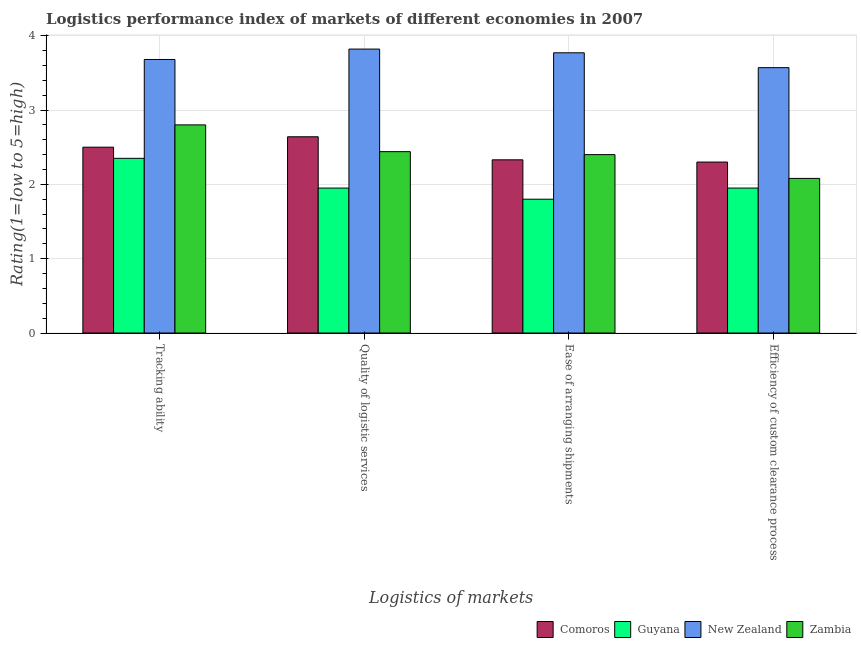How many bars are there on the 2nd tick from the left?
Offer a terse response. 4. How many bars are there on the 3rd tick from the right?
Ensure brevity in your answer.  4. What is the label of the 4th group of bars from the left?
Provide a succinct answer. Efficiency of custom clearance process. What is the lpi rating of ease of arranging shipments in Zambia?
Offer a terse response. 2.4. Across all countries, what is the maximum lpi rating of tracking ability?
Keep it short and to the point. 3.68. Across all countries, what is the minimum lpi rating of quality of logistic services?
Keep it short and to the point. 1.95. In which country was the lpi rating of efficiency of custom clearance process maximum?
Offer a terse response. New Zealand. In which country was the lpi rating of ease of arranging shipments minimum?
Give a very brief answer. Guyana. What is the difference between the lpi rating of quality of logistic services in New Zealand and that in Zambia?
Offer a very short reply. 1.38. What is the difference between the lpi rating of efficiency of custom clearance process in Zambia and the lpi rating of tracking ability in Comoros?
Make the answer very short. -0.42. What is the average lpi rating of efficiency of custom clearance process per country?
Your response must be concise. 2.48. What is the difference between the lpi rating of ease of arranging shipments and lpi rating of quality of logistic services in New Zealand?
Provide a short and direct response. -0.05. In how many countries, is the lpi rating of ease of arranging shipments greater than 3.2 ?
Ensure brevity in your answer.  1. What is the ratio of the lpi rating of quality of logistic services in Zambia to that in Comoros?
Keep it short and to the point. 0.92. What is the difference between the highest and the second highest lpi rating of quality of logistic services?
Your answer should be very brief. 1.18. What is the difference between the highest and the lowest lpi rating of tracking ability?
Make the answer very short. 1.33. Is the sum of the lpi rating of ease of arranging shipments in New Zealand and Guyana greater than the maximum lpi rating of tracking ability across all countries?
Offer a terse response. Yes. Is it the case that in every country, the sum of the lpi rating of tracking ability and lpi rating of ease of arranging shipments is greater than the sum of lpi rating of quality of logistic services and lpi rating of efficiency of custom clearance process?
Make the answer very short. No. What does the 4th bar from the left in Quality of logistic services represents?
Offer a very short reply. Zambia. What does the 1st bar from the right in Efficiency of custom clearance process represents?
Your answer should be very brief. Zambia. How many bars are there?
Provide a succinct answer. 16. Are all the bars in the graph horizontal?
Provide a succinct answer. No. What is the difference between two consecutive major ticks on the Y-axis?
Provide a short and direct response. 1. Does the graph contain any zero values?
Give a very brief answer. No. Does the graph contain grids?
Give a very brief answer. Yes. Where does the legend appear in the graph?
Your response must be concise. Bottom right. How many legend labels are there?
Offer a terse response. 4. How are the legend labels stacked?
Ensure brevity in your answer.  Horizontal. What is the title of the graph?
Ensure brevity in your answer.  Logistics performance index of markets of different economies in 2007. What is the label or title of the X-axis?
Ensure brevity in your answer.  Logistics of markets. What is the label or title of the Y-axis?
Your answer should be compact. Rating(1=low to 5=high). What is the Rating(1=low to 5=high) of Guyana in Tracking ability?
Offer a very short reply. 2.35. What is the Rating(1=low to 5=high) of New Zealand in Tracking ability?
Your answer should be compact. 3.68. What is the Rating(1=low to 5=high) in Zambia in Tracking ability?
Your answer should be compact. 2.8. What is the Rating(1=low to 5=high) of Comoros in Quality of logistic services?
Provide a succinct answer. 2.64. What is the Rating(1=low to 5=high) of Guyana in Quality of logistic services?
Provide a succinct answer. 1.95. What is the Rating(1=low to 5=high) of New Zealand in Quality of logistic services?
Offer a very short reply. 3.82. What is the Rating(1=low to 5=high) in Zambia in Quality of logistic services?
Offer a very short reply. 2.44. What is the Rating(1=low to 5=high) of Comoros in Ease of arranging shipments?
Make the answer very short. 2.33. What is the Rating(1=low to 5=high) in Guyana in Ease of arranging shipments?
Offer a very short reply. 1.8. What is the Rating(1=low to 5=high) of New Zealand in Ease of arranging shipments?
Provide a short and direct response. 3.77. What is the Rating(1=low to 5=high) in Zambia in Ease of arranging shipments?
Ensure brevity in your answer.  2.4. What is the Rating(1=low to 5=high) of Comoros in Efficiency of custom clearance process?
Ensure brevity in your answer.  2.3. What is the Rating(1=low to 5=high) of Guyana in Efficiency of custom clearance process?
Offer a very short reply. 1.95. What is the Rating(1=low to 5=high) in New Zealand in Efficiency of custom clearance process?
Make the answer very short. 3.57. What is the Rating(1=low to 5=high) in Zambia in Efficiency of custom clearance process?
Your answer should be compact. 2.08. Across all Logistics of markets, what is the maximum Rating(1=low to 5=high) of Comoros?
Provide a succinct answer. 2.64. Across all Logistics of markets, what is the maximum Rating(1=low to 5=high) of Guyana?
Your answer should be compact. 2.35. Across all Logistics of markets, what is the maximum Rating(1=low to 5=high) in New Zealand?
Provide a succinct answer. 3.82. Across all Logistics of markets, what is the minimum Rating(1=low to 5=high) in New Zealand?
Your response must be concise. 3.57. Across all Logistics of markets, what is the minimum Rating(1=low to 5=high) of Zambia?
Your response must be concise. 2.08. What is the total Rating(1=low to 5=high) of Comoros in the graph?
Provide a short and direct response. 9.77. What is the total Rating(1=low to 5=high) of Guyana in the graph?
Offer a very short reply. 8.05. What is the total Rating(1=low to 5=high) of New Zealand in the graph?
Your answer should be very brief. 14.84. What is the total Rating(1=low to 5=high) in Zambia in the graph?
Your answer should be compact. 9.72. What is the difference between the Rating(1=low to 5=high) in Comoros in Tracking ability and that in Quality of logistic services?
Provide a succinct answer. -0.14. What is the difference between the Rating(1=low to 5=high) of Guyana in Tracking ability and that in Quality of logistic services?
Ensure brevity in your answer.  0.4. What is the difference between the Rating(1=low to 5=high) in New Zealand in Tracking ability and that in Quality of logistic services?
Offer a very short reply. -0.14. What is the difference between the Rating(1=low to 5=high) of Zambia in Tracking ability and that in Quality of logistic services?
Give a very brief answer. 0.36. What is the difference between the Rating(1=low to 5=high) in Comoros in Tracking ability and that in Ease of arranging shipments?
Ensure brevity in your answer.  0.17. What is the difference between the Rating(1=low to 5=high) in Guyana in Tracking ability and that in Ease of arranging shipments?
Make the answer very short. 0.55. What is the difference between the Rating(1=low to 5=high) in New Zealand in Tracking ability and that in Ease of arranging shipments?
Offer a very short reply. -0.09. What is the difference between the Rating(1=low to 5=high) in Comoros in Tracking ability and that in Efficiency of custom clearance process?
Provide a succinct answer. 0.2. What is the difference between the Rating(1=low to 5=high) in New Zealand in Tracking ability and that in Efficiency of custom clearance process?
Give a very brief answer. 0.11. What is the difference between the Rating(1=low to 5=high) of Zambia in Tracking ability and that in Efficiency of custom clearance process?
Provide a short and direct response. 0.72. What is the difference between the Rating(1=low to 5=high) in Comoros in Quality of logistic services and that in Ease of arranging shipments?
Give a very brief answer. 0.31. What is the difference between the Rating(1=low to 5=high) of New Zealand in Quality of logistic services and that in Ease of arranging shipments?
Provide a short and direct response. 0.05. What is the difference between the Rating(1=low to 5=high) in Zambia in Quality of logistic services and that in Ease of arranging shipments?
Give a very brief answer. 0.04. What is the difference between the Rating(1=low to 5=high) in Comoros in Quality of logistic services and that in Efficiency of custom clearance process?
Give a very brief answer. 0.34. What is the difference between the Rating(1=low to 5=high) in Guyana in Quality of logistic services and that in Efficiency of custom clearance process?
Give a very brief answer. 0. What is the difference between the Rating(1=low to 5=high) of Zambia in Quality of logistic services and that in Efficiency of custom clearance process?
Ensure brevity in your answer.  0.36. What is the difference between the Rating(1=low to 5=high) in Comoros in Ease of arranging shipments and that in Efficiency of custom clearance process?
Your answer should be compact. 0.03. What is the difference between the Rating(1=low to 5=high) of Zambia in Ease of arranging shipments and that in Efficiency of custom clearance process?
Offer a terse response. 0.32. What is the difference between the Rating(1=low to 5=high) in Comoros in Tracking ability and the Rating(1=low to 5=high) in Guyana in Quality of logistic services?
Your answer should be compact. 0.55. What is the difference between the Rating(1=low to 5=high) in Comoros in Tracking ability and the Rating(1=low to 5=high) in New Zealand in Quality of logistic services?
Offer a very short reply. -1.32. What is the difference between the Rating(1=low to 5=high) of Guyana in Tracking ability and the Rating(1=low to 5=high) of New Zealand in Quality of logistic services?
Ensure brevity in your answer.  -1.47. What is the difference between the Rating(1=low to 5=high) in Guyana in Tracking ability and the Rating(1=low to 5=high) in Zambia in Quality of logistic services?
Your answer should be compact. -0.09. What is the difference between the Rating(1=low to 5=high) in New Zealand in Tracking ability and the Rating(1=low to 5=high) in Zambia in Quality of logistic services?
Make the answer very short. 1.24. What is the difference between the Rating(1=low to 5=high) in Comoros in Tracking ability and the Rating(1=low to 5=high) in Guyana in Ease of arranging shipments?
Make the answer very short. 0.7. What is the difference between the Rating(1=low to 5=high) of Comoros in Tracking ability and the Rating(1=low to 5=high) of New Zealand in Ease of arranging shipments?
Give a very brief answer. -1.27. What is the difference between the Rating(1=low to 5=high) of Comoros in Tracking ability and the Rating(1=low to 5=high) of Zambia in Ease of arranging shipments?
Your answer should be compact. 0.1. What is the difference between the Rating(1=low to 5=high) in Guyana in Tracking ability and the Rating(1=low to 5=high) in New Zealand in Ease of arranging shipments?
Your answer should be compact. -1.42. What is the difference between the Rating(1=low to 5=high) of New Zealand in Tracking ability and the Rating(1=low to 5=high) of Zambia in Ease of arranging shipments?
Your answer should be very brief. 1.28. What is the difference between the Rating(1=low to 5=high) in Comoros in Tracking ability and the Rating(1=low to 5=high) in Guyana in Efficiency of custom clearance process?
Ensure brevity in your answer.  0.55. What is the difference between the Rating(1=low to 5=high) in Comoros in Tracking ability and the Rating(1=low to 5=high) in New Zealand in Efficiency of custom clearance process?
Your response must be concise. -1.07. What is the difference between the Rating(1=low to 5=high) of Comoros in Tracking ability and the Rating(1=low to 5=high) of Zambia in Efficiency of custom clearance process?
Your answer should be compact. 0.42. What is the difference between the Rating(1=low to 5=high) of Guyana in Tracking ability and the Rating(1=low to 5=high) of New Zealand in Efficiency of custom clearance process?
Provide a succinct answer. -1.22. What is the difference between the Rating(1=low to 5=high) in Guyana in Tracking ability and the Rating(1=low to 5=high) in Zambia in Efficiency of custom clearance process?
Your response must be concise. 0.27. What is the difference between the Rating(1=low to 5=high) of Comoros in Quality of logistic services and the Rating(1=low to 5=high) of Guyana in Ease of arranging shipments?
Your answer should be very brief. 0.84. What is the difference between the Rating(1=low to 5=high) of Comoros in Quality of logistic services and the Rating(1=low to 5=high) of New Zealand in Ease of arranging shipments?
Your response must be concise. -1.13. What is the difference between the Rating(1=low to 5=high) in Comoros in Quality of logistic services and the Rating(1=low to 5=high) in Zambia in Ease of arranging shipments?
Make the answer very short. 0.24. What is the difference between the Rating(1=low to 5=high) of Guyana in Quality of logistic services and the Rating(1=low to 5=high) of New Zealand in Ease of arranging shipments?
Give a very brief answer. -1.82. What is the difference between the Rating(1=low to 5=high) in Guyana in Quality of logistic services and the Rating(1=low to 5=high) in Zambia in Ease of arranging shipments?
Ensure brevity in your answer.  -0.45. What is the difference between the Rating(1=low to 5=high) of New Zealand in Quality of logistic services and the Rating(1=low to 5=high) of Zambia in Ease of arranging shipments?
Keep it short and to the point. 1.42. What is the difference between the Rating(1=low to 5=high) of Comoros in Quality of logistic services and the Rating(1=low to 5=high) of Guyana in Efficiency of custom clearance process?
Your answer should be very brief. 0.69. What is the difference between the Rating(1=low to 5=high) of Comoros in Quality of logistic services and the Rating(1=low to 5=high) of New Zealand in Efficiency of custom clearance process?
Your answer should be very brief. -0.93. What is the difference between the Rating(1=low to 5=high) of Comoros in Quality of logistic services and the Rating(1=low to 5=high) of Zambia in Efficiency of custom clearance process?
Make the answer very short. 0.56. What is the difference between the Rating(1=low to 5=high) of Guyana in Quality of logistic services and the Rating(1=low to 5=high) of New Zealand in Efficiency of custom clearance process?
Give a very brief answer. -1.62. What is the difference between the Rating(1=low to 5=high) of Guyana in Quality of logistic services and the Rating(1=low to 5=high) of Zambia in Efficiency of custom clearance process?
Provide a succinct answer. -0.13. What is the difference between the Rating(1=low to 5=high) in New Zealand in Quality of logistic services and the Rating(1=low to 5=high) in Zambia in Efficiency of custom clearance process?
Give a very brief answer. 1.74. What is the difference between the Rating(1=low to 5=high) in Comoros in Ease of arranging shipments and the Rating(1=low to 5=high) in Guyana in Efficiency of custom clearance process?
Your answer should be compact. 0.38. What is the difference between the Rating(1=low to 5=high) in Comoros in Ease of arranging shipments and the Rating(1=low to 5=high) in New Zealand in Efficiency of custom clearance process?
Your answer should be compact. -1.24. What is the difference between the Rating(1=low to 5=high) in Comoros in Ease of arranging shipments and the Rating(1=low to 5=high) in Zambia in Efficiency of custom clearance process?
Make the answer very short. 0.25. What is the difference between the Rating(1=low to 5=high) in Guyana in Ease of arranging shipments and the Rating(1=low to 5=high) in New Zealand in Efficiency of custom clearance process?
Offer a terse response. -1.77. What is the difference between the Rating(1=low to 5=high) of Guyana in Ease of arranging shipments and the Rating(1=low to 5=high) of Zambia in Efficiency of custom clearance process?
Provide a short and direct response. -0.28. What is the difference between the Rating(1=low to 5=high) in New Zealand in Ease of arranging shipments and the Rating(1=low to 5=high) in Zambia in Efficiency of custom clearance process?
Keep it short and to the point. 1.69. What is the average Rating(1=low to 5=high) in Comoros per Logistics of markets?
Provide a short and direct response. 2.44. What is the average Rating(1=low to 5=high) in Guyana per Logistics of markets?
Make the answer very short. 2.01. What is the average Rating(1=low to 5=high) of New Zealand per Logistics of markets?
Provide a succinct answer. 3.71. What is the average Rating(1=low to 5=high) in Zambia per Logistics of markets?
Provide a short and direct response. 2.43. What is the difference between the Rating(1=low to 5=high) in Comoros and Rating(1=low to 5=high) in New Zealand in Tracking ability?
Your answer should be very brief. -1.18. What is the difference between the Rating(1=low to 5=high) in Comoros and Rating(1=low to 5=high) in Zambia in Tracking ability?
Keep it short and to the point. -0.3. What is the difference between the Rating(1=low to 5=high) of Guyana and Rating(1=low to 5=high) of New Zealand in Tracking ability?
Provide a short and direct response. -1.33. What is the difference between the Rating(1=low to 5=high) in Guyana and Rating(1=low to 5=high) in Zambia in Tracking ability?
Your answer should be very brief. -0.45. What is the difference between the Rating(1=low to 5=high) of New Zealand and Rating(1=low to 5=high) of Zambia in Tracking ability?
Your answer should be very brief. 0.88. What is the difference between the Rating(1=low to 5=high) of Comoros and Rating(1=low to 5=high) of Guyana in Quality of logistic services?
Provide a succinct answer. 0.69. What is the difference between the Rating(1=low to 5=high) in Comoros and Rating(1=low to 5=high) in New Zealand in Quality of logistic services?
Ensure brevity in your answer.  -1.18. What is the difference between the Rating(1=low to 5=high) of Comoros and Rating(1=low to 5=high) of Zambia in Quality of logistic services?
Your response must be concise. 0.2. What is the difference between the Rating(1=low to 5=high) in Guyana and Rating(1=low to 5=high) in New Zealand in Quality of logistic services?
Provide a short and direct response. -1.87. What is the difference between the Rating(1=low to 5=high) in Guyana and Rating(1=low to 5=high) in Zambia in Quality of logistic services?
Your answer should be compact. -0.49. What is the difference between the Rating(1=low to 5=high) in New Zealand and Rating(1=low to 5=high) in Zambia in Quality of logistic services?
Your answer should be very brief. 1.38. What is the difference between the Rating(1=low to 5=high) of Comoros and Rating(1=low to 5=high) of Guyana in Ease of arranging shipments?
Ensure brevity in your answer.  0.53. What is the difference between the Rating(1=low to 5=high) in Comoros and Rating(1=low to 5=high) in New Zealand in Ease of arranging shipments?
Keep it short and to the point. -1.44. What is the difference between the Rating(1=low to 5=high) of Comoros and Rating(1=low to 5=high) of Zambia in Ease of arranging shipments?
Offer a very short reply. -0.07. What is the difference between the Rating(1=low to 5=high) in Guyana and Rating(1=low to 5=high) in New Zealand in Ease of arranging shipments?
Your answer should be very brief. -1.97. What is the difference between the Rating(1=low to 5=high) in New Zealand and Rating(1=low to 5=high) in Zambia in Ease of arranging shipments?
Your answer should be very brief. 1.37. What is the difference between the Rating(1=low to 5=high) in Comoros and Rating(1=low to 5=high) in New Zealand in Efficiency of custom clearance process?
Make the answer very short. -1.27. What is the difference between the Rating(1=low to 5=high) of Comoros and Rating(1=low to 5=high) of Zambia in Efficiency of custom clearance process?
Provide a short and direct response. 0.22. What is the difference between the Rating(1=low to 5=high) in Guyana and Rating(1=low to 5=high) in New Zealand in Efficiency of custom clearance process?
Provide a succinct answer. -1.62. What is the difference between the Rating(1=low to 5=high) in Guyana and Rating(1=low to 5=high) in Zambia in Efficiency of custom clearance process?
Keep it short and to the point. -0.13. What is the difference between the Rating(1=low to 5=high) in New Zealand and Rating(1=low to 5=high) in Zambia in Efficiency of custom clearance process?
Ensure brevity in your answer.  1.49. What is the ratio of the Rating(1=low to 5=high) in Comoros in Tracking ability to that in Quality of logistic services?
Offer a terse response. 0.95. What is the ratio of the Rating(1=low to 5=high) in Guyana in Tracking ability to that in Quality of logistic services?
Keep it short and to the point. 1.21. What is the ratio of the Rating(1=low to 5=high) of New Zealand in Tracking ability to that in Quality of logistic services?
Provide a succinct answer. 0.96. What is the ratio of the Rating(1=low to 5=high) in Zambia in Tracking ability to that in Quality of logistic services?
Your answer should be very brief. 1.15. What is the ratio of the Rating(1=low to 5=high) of Comoros in Tracking ability to that in Ease of arranging shipments?
Give a very brief answer. 1.07. What is the ratio of the Rating(1=low to 5=high) in Guyana in Tracking ability to that in Ease of arranging shipments?
Offer a terse response. 1.31. What is the ratio of the Rating(1=low to 5=high) of New Zealand in Tracking ability to that in Ease of arranging shipments?
Provide a succinct answer. 0.98. What is the ratio of the Rating(1=low to 5=high) of Comoros in Tracking ability to that in Efficiency of custom clearance process?
Provide a succinct answer. 1.09. What is the ratio of the Rating(1=low to 5=high) of Guyana in Tracking ability to that in Efficiency of custom clearance process?
Give a very brief answer. 1.21. What is the ratio of the Rating(1=low to 5=high) of New Zealand in Tracking ability to that in Efficiency of custom clearance process?
Provide a succinct answer. 1.03. What is the ratio of the Rating(1=low to 5=high) in Zambia in Tracking ability to that in Efficiency of custom clearance process?
Provide a succinct answer. 1.35. What is the ratio of the Rating(1=low to 5=high) of Comoros in Quality of logistic services to that in Ease of arranging shipments?
Provide a short and direct response. 1.13. What is the ratio of the Rating(1=low to 5=high) in Guyana in Quality of logistic services to that in Ease of arranging shipments?
Offer a terse response. 1.08. What is the ratio of the Rating(1=low to 5=high) of New Zealand in Quality of logistic services to that in Ease of arranging shipments?
Your answer should be compact. 1.01. What is the ratio of the Rating(1=low to 5=high) in Zambia in Quality of logistic services to that in Ease of arranging shipments?
Ensure brevity in your answer.  1.02. What is the ratio of the Rating(1=low to 5=high) in Comoros in Quality of logistic services to that in Efficiency of custom clearance process?
Keep it short and to the point. 1.15. What is the ratio of the Rating(1=low to 5=high) of New Zealand in Quality of logistic services to that in Efficiency of custom clearance process?
Your answer should be very brief. 1.07. What is the ratio of the Rating(1=low to 5=high) in Zambia in Quality of logistic services to that in Efficiency of custom clearance process?
Make the answer very short. 1.17. What is the ratio of the Rating(1=low to 5=high) of New Zealand in Ease of arranging shipments to that in Efficiency of custom clearance process?
Your answer should be very brief. 1.06. What is the ratio of the Rating(1=low to 5=high) in Zambia in Ease of arranging shipments to that in Efficiency of custom clearance process?
Offer a terse response. 1.15. What is the difference between the highest and the second highest Rating(1=low to 5=high) of Comoros?
Offer a very short reply. 0.14. What is the difference between the highest and the second highest Rating(1=low to 5=high) in New Zealand?
Keep it short and to the point. 0.05. What is the difference between the highest and the second highest Rating(1=low to 5=high) in Zambia?
Provide a succinct answer. 0.36. What is the difference between the highest and the lowest Rating(1=low to 5=high) in Comoros?
Offer a terse response. 0.34. What is the difference between the highest and the lowest Rating(1=low to 5=high) in Guyana?
Keep it short and to the point. 0.55. What is the difference between the highest and the lowest Rating(1=low to 5=high) in Zambia?
Give a very brief answer. 0.72. 